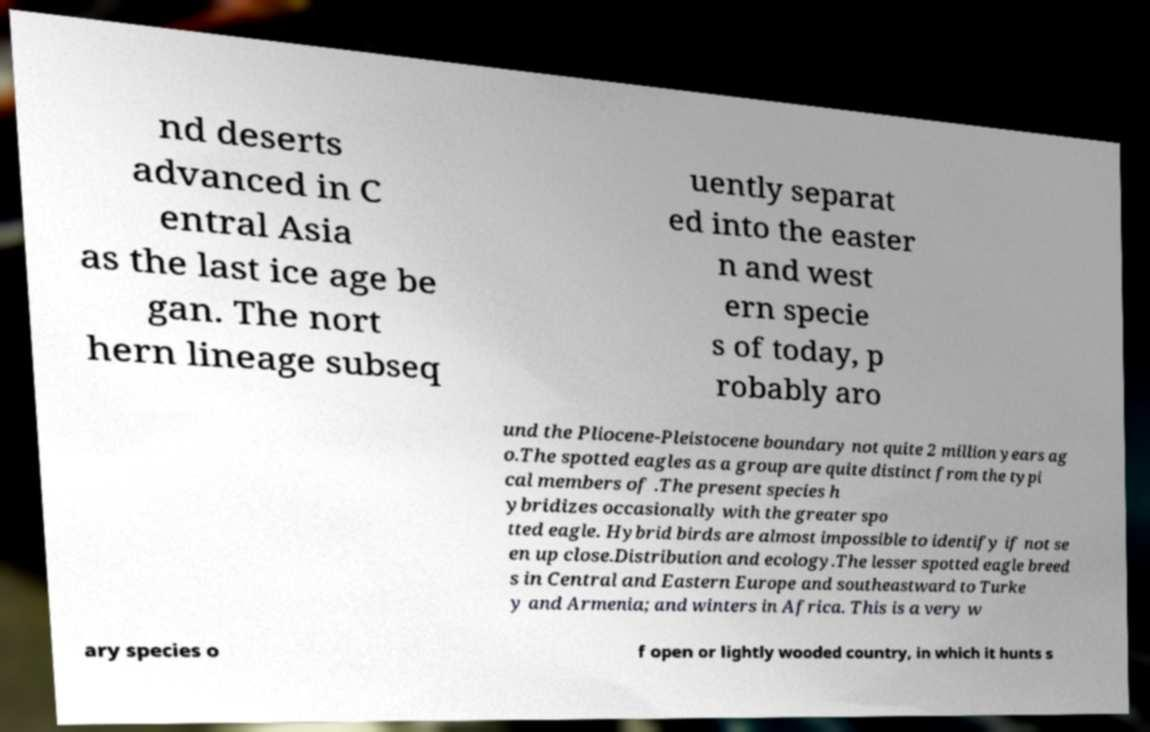Please read and relay the text visible in this image. What does it say? nd deserts advanced in C entral Asia as the last ice age be gan. The nort hern lineage subseq uently separat ed into the easter n and west ern specie s of today, p robably aro und the Pliocene-Pleistocene boundary not quite 2 million years ag o.The spotted eagles as a group are quite distinct from the typi cal members of .The present species h ybridizes occasionally with the greater spo tted eagle. Hybrid birds are almost impossible to identify if not se en up close.Distribution and ecology.The lesser spotted eagle breed s in Central and Eastern Europe and southeastward to Turke y and Armenia; and winters in Africa. This is a very w ary species o f open or lightly wooded country, in which it hunts s 